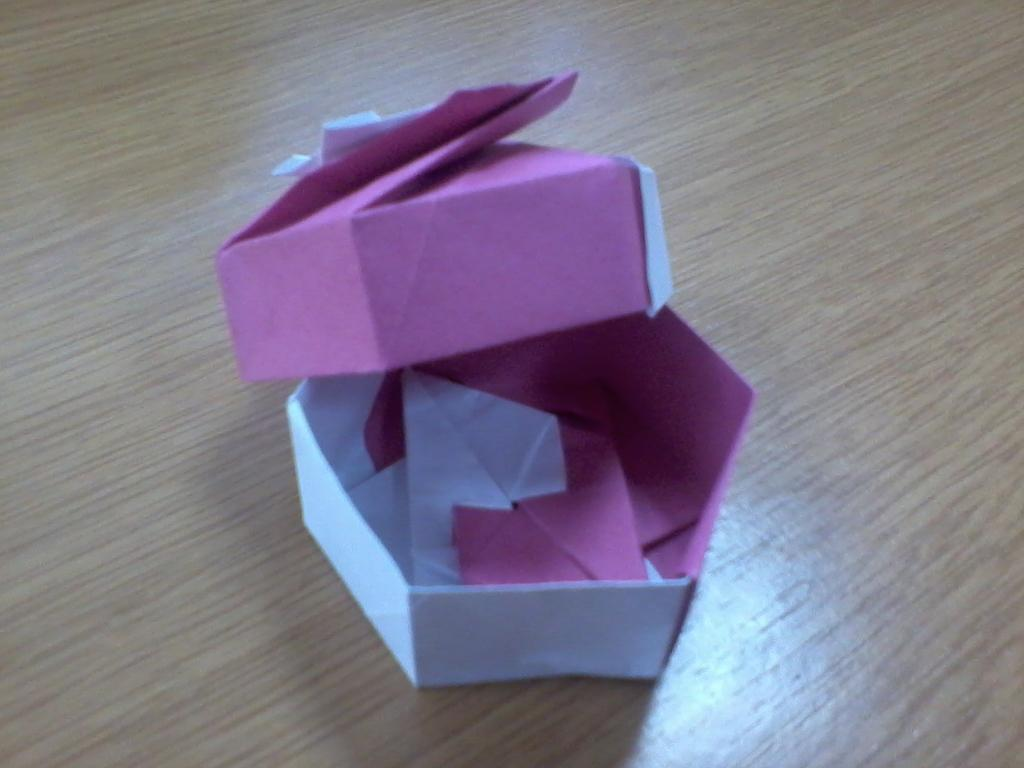What is the main object in the image? There is a box made with paper in the image. What material is the surface behind the box made of? There is a wooden surface in the background of the image. What is the reason for the train's sudden stop in the image? There is no train present in the image; it only features a paper box and a wooden surface. 